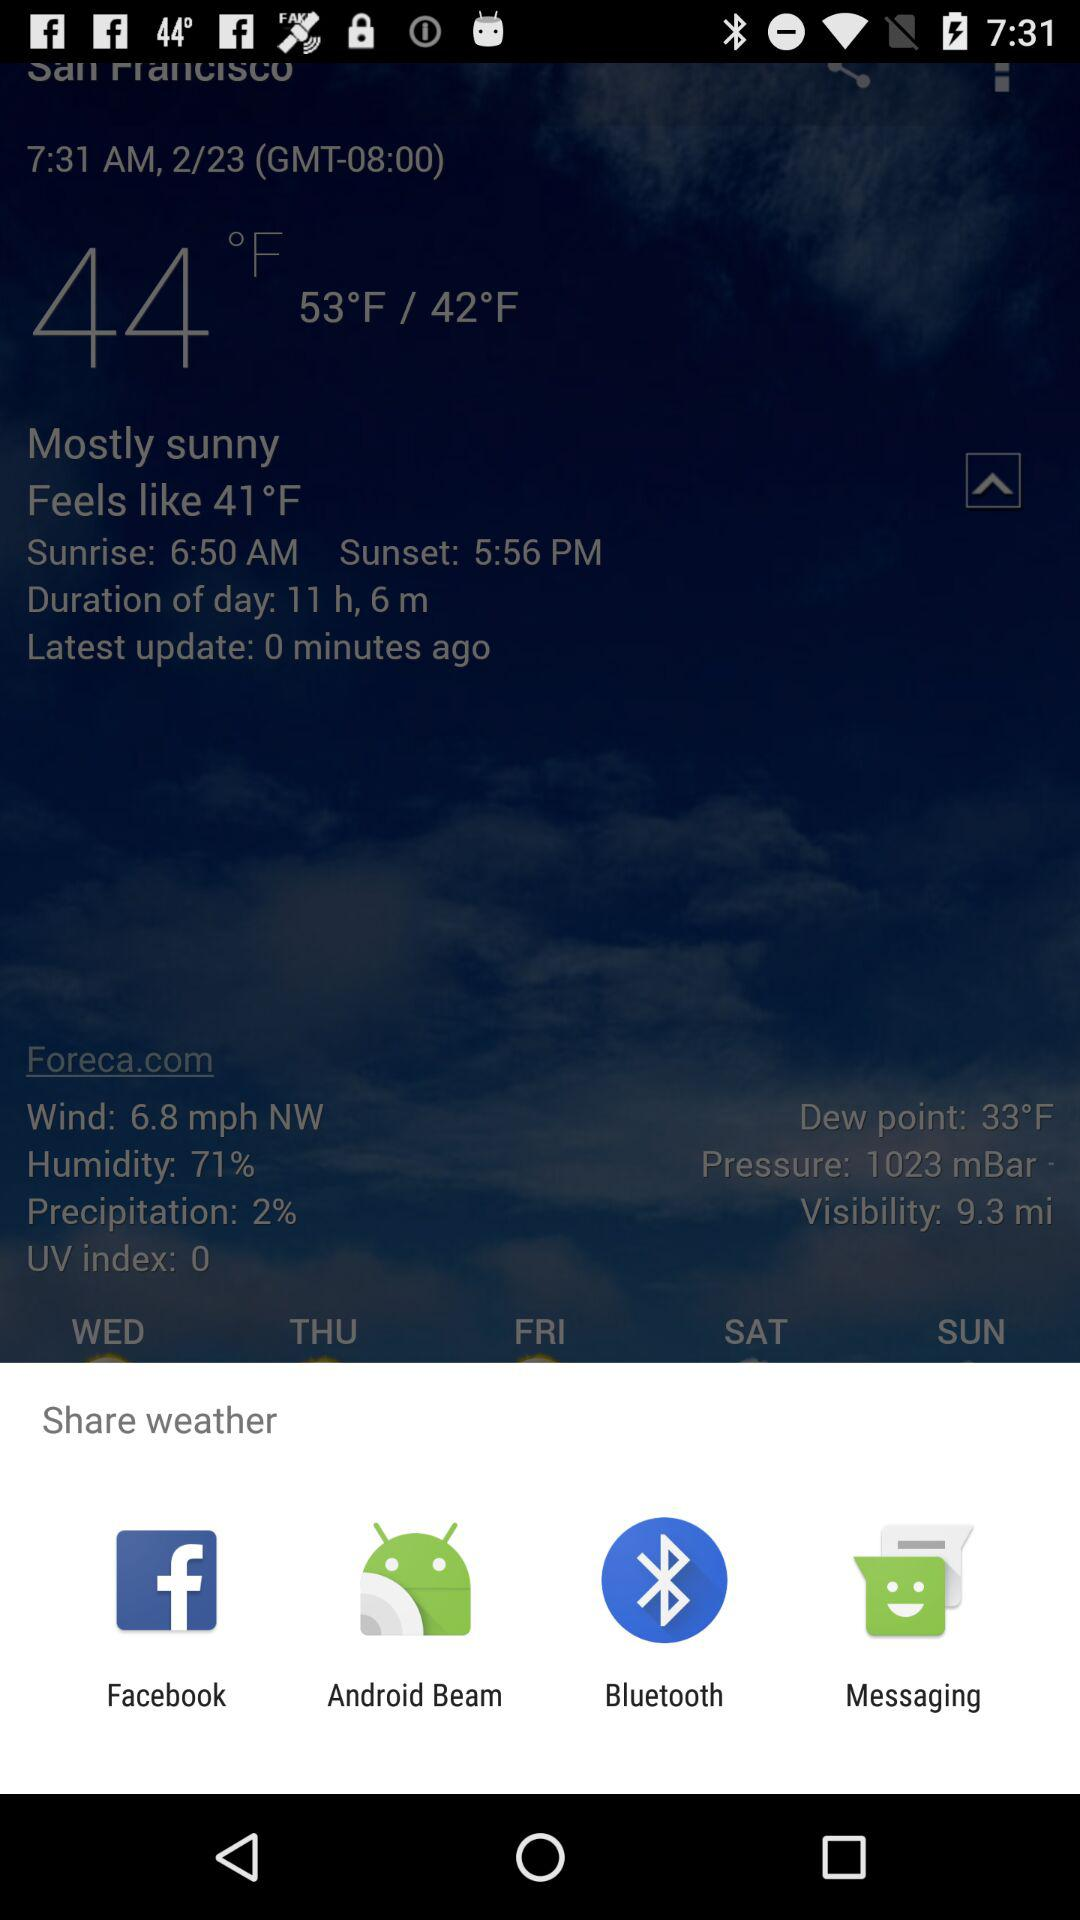Through which application the weather can be shared? You can share the weather through "Facebook", "Android Beam", "Bluetooth" and "Messaging". 